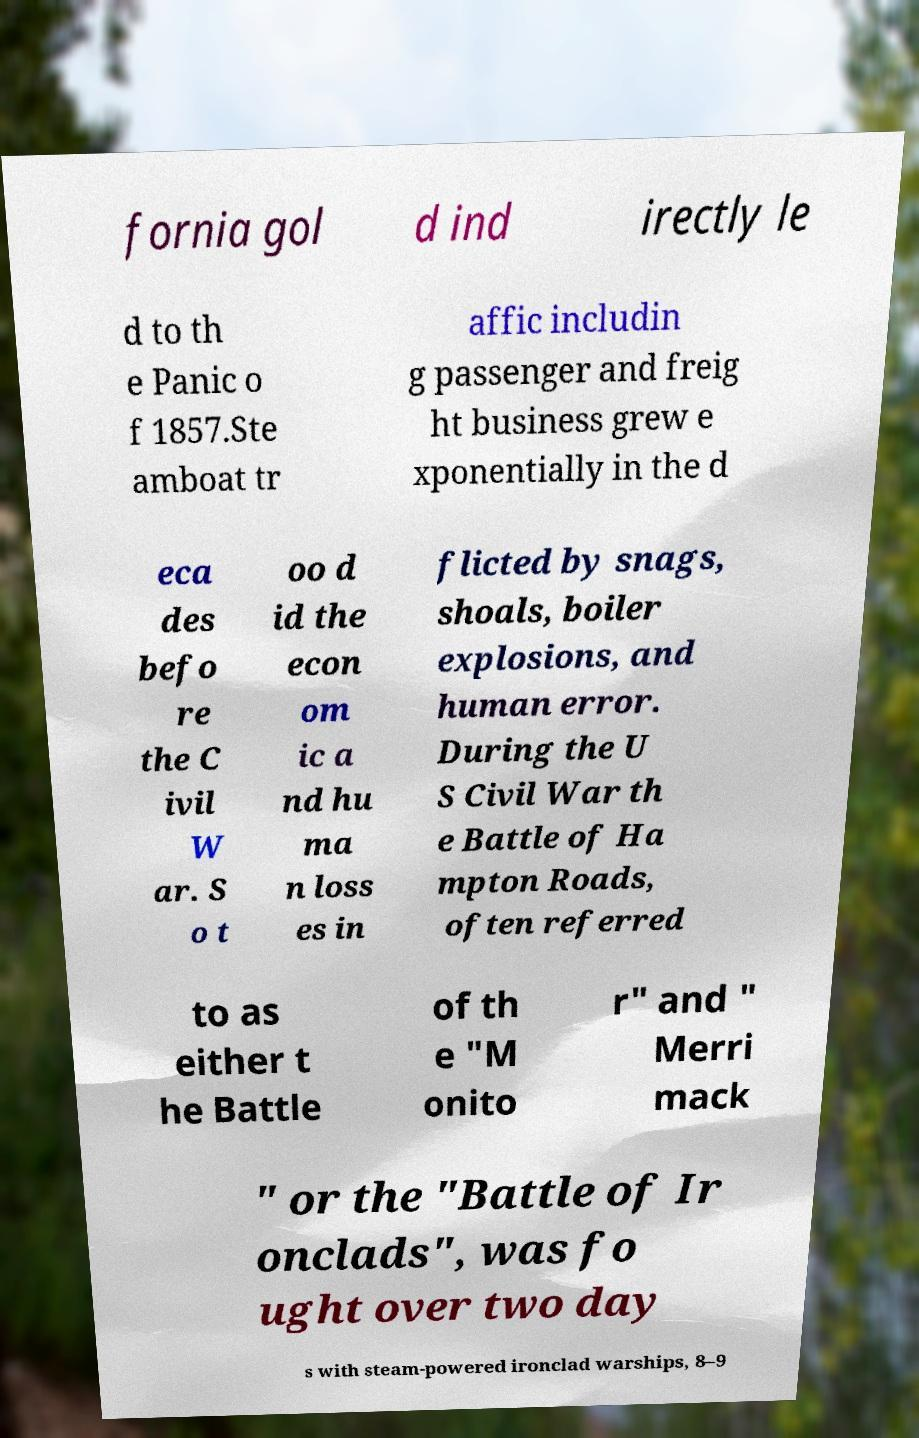For documentation purposes, I need the text within this image transcribed. Could you provide that? fornia gol d ind irectly le d to th e Panic o f 1857.Ste amboat tr affic includin g passenger and freig ht business grew e xponentially in the d eca des befo re the C ivil W ar. S o t oo d id the econ om ic a nd hu ma n loss es in flicted by snags, shoals, boiler explosions, and human error. During the U S Civil War th e Battle of Ha mpton Roads, often referred to as either t he Battle of th e "M onito r" and " Merri mack " or the "Battle of Ir onclads", was fo ught over two day s with steam-powered ironclad warships, 8–9 